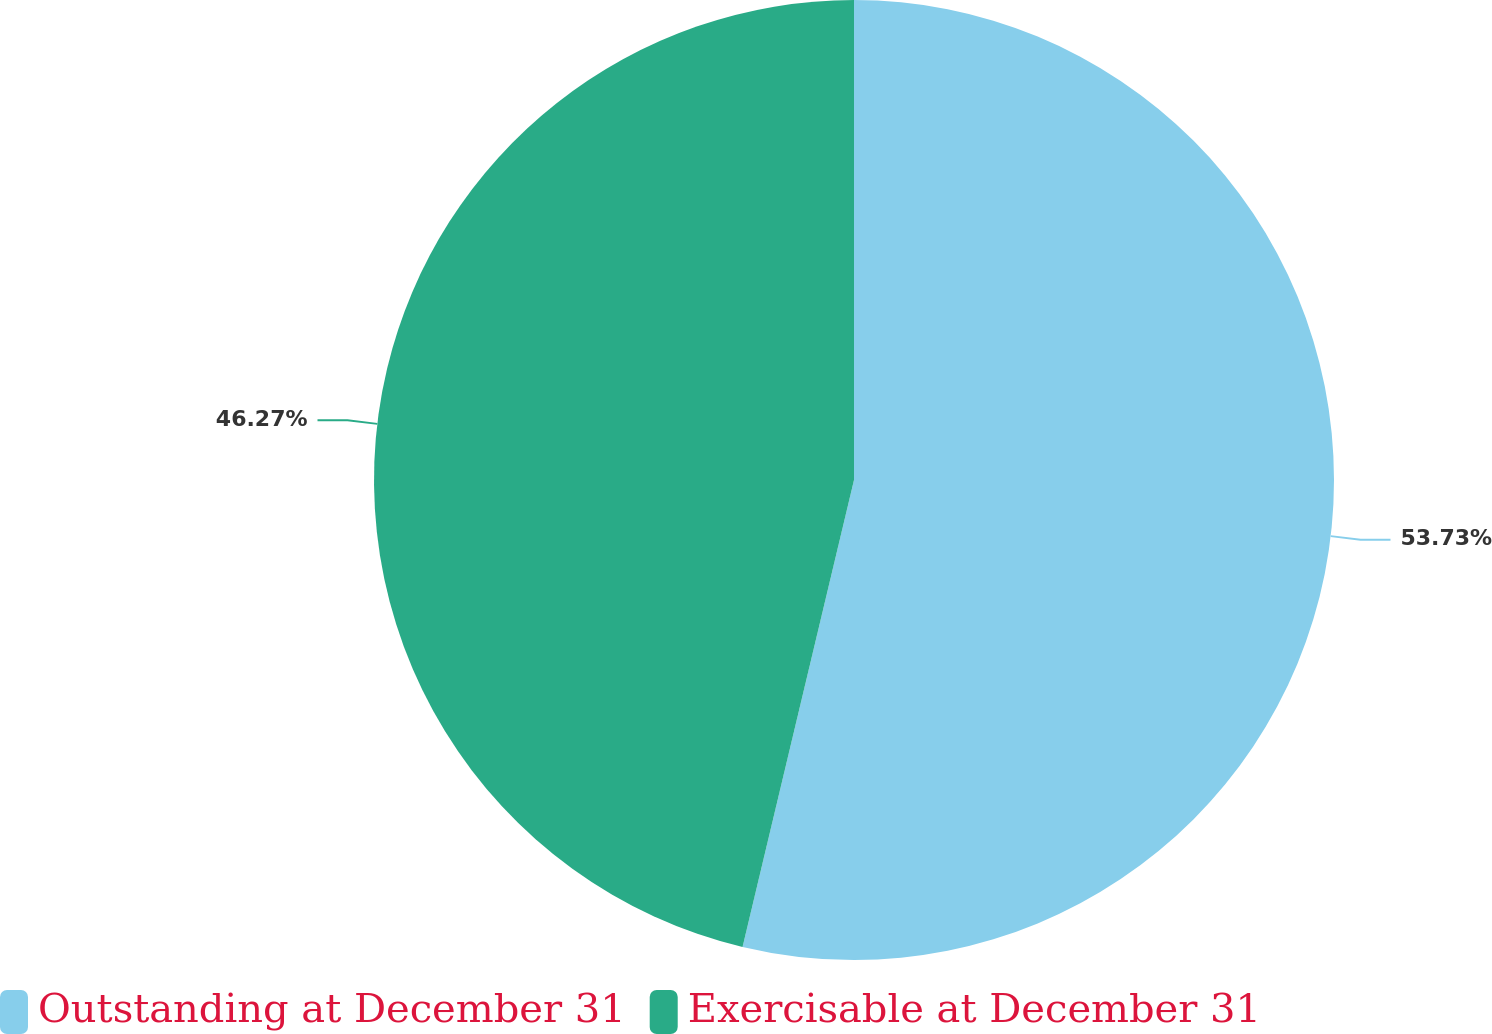Convert chart. <chart><loc_0><loc_0><loc_500><loc_500><pie_chart><fcel>Outstanding at December 31<fcel>Exercisable at December 31<nl><fcel>53.73%<fcel>46.27%<nl></chart> 